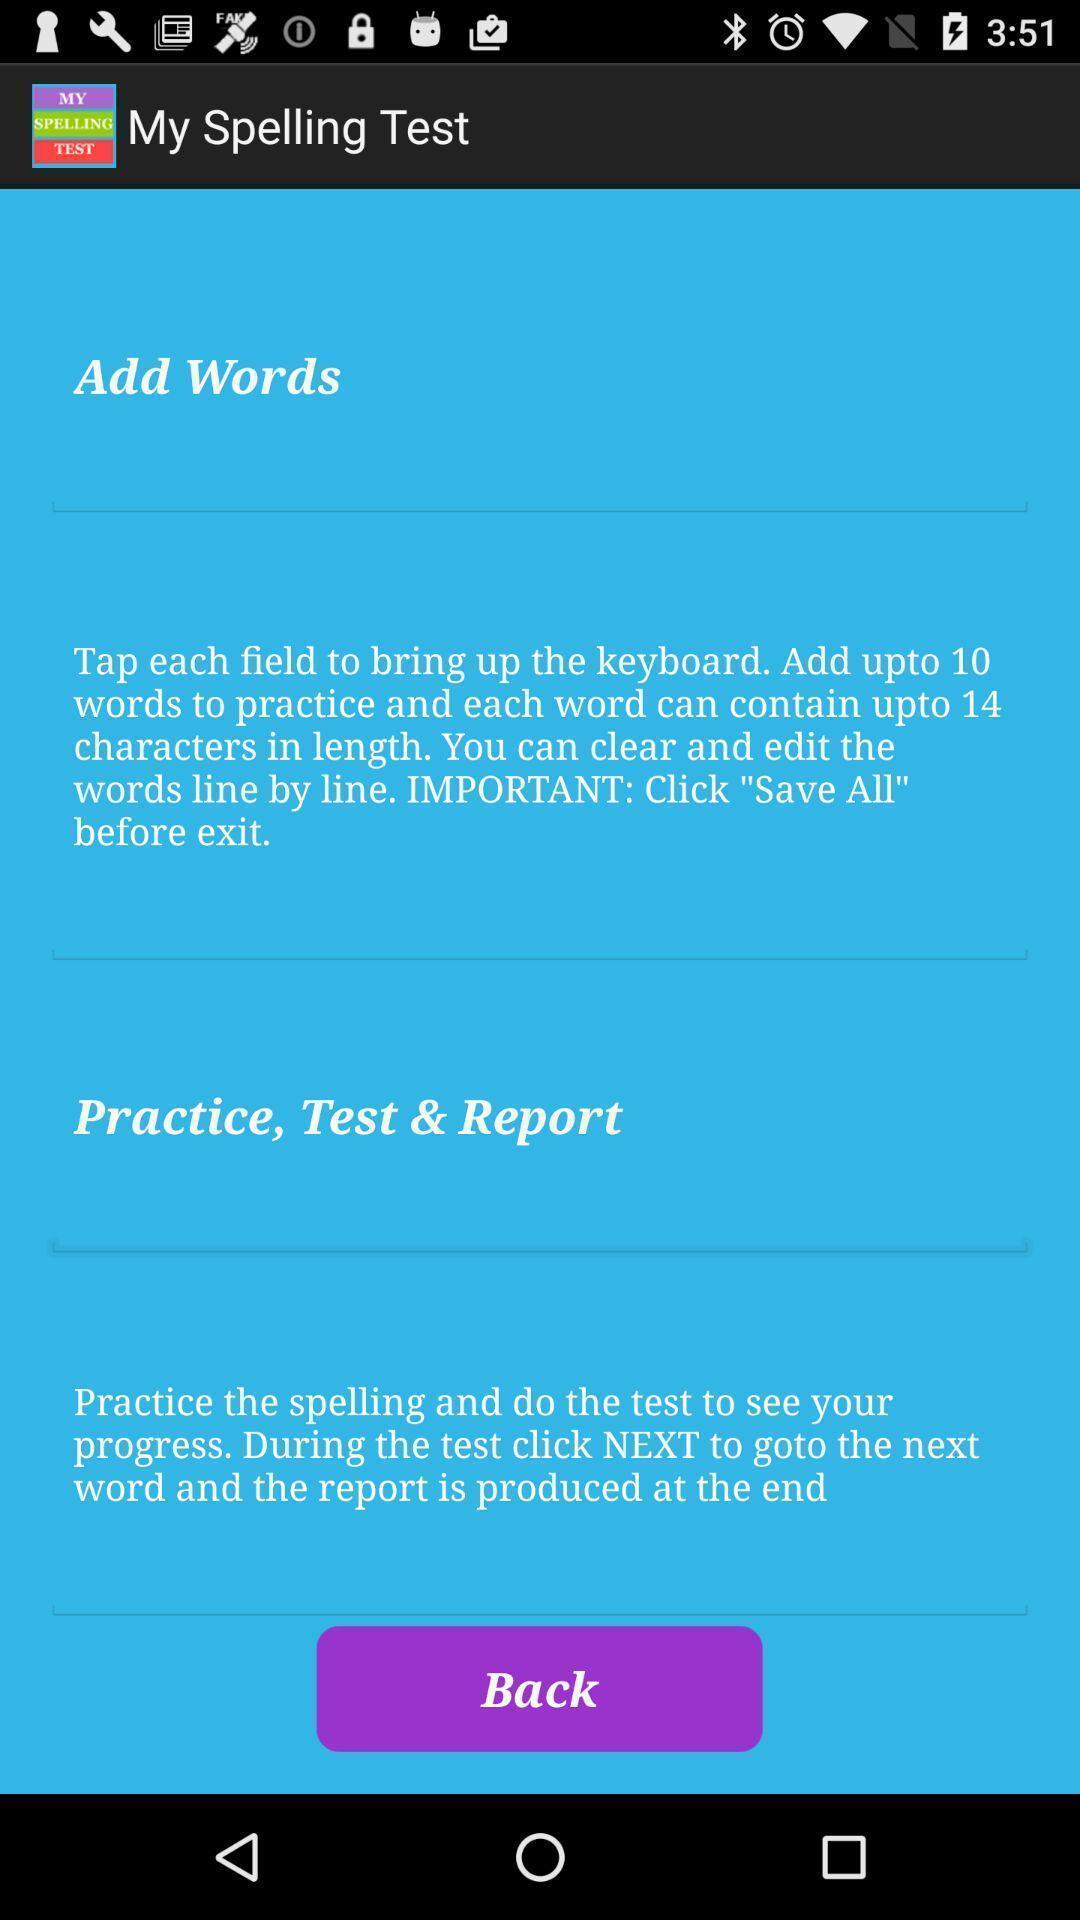Summarize the information in this screenshot. Screen displaying typing test application. 